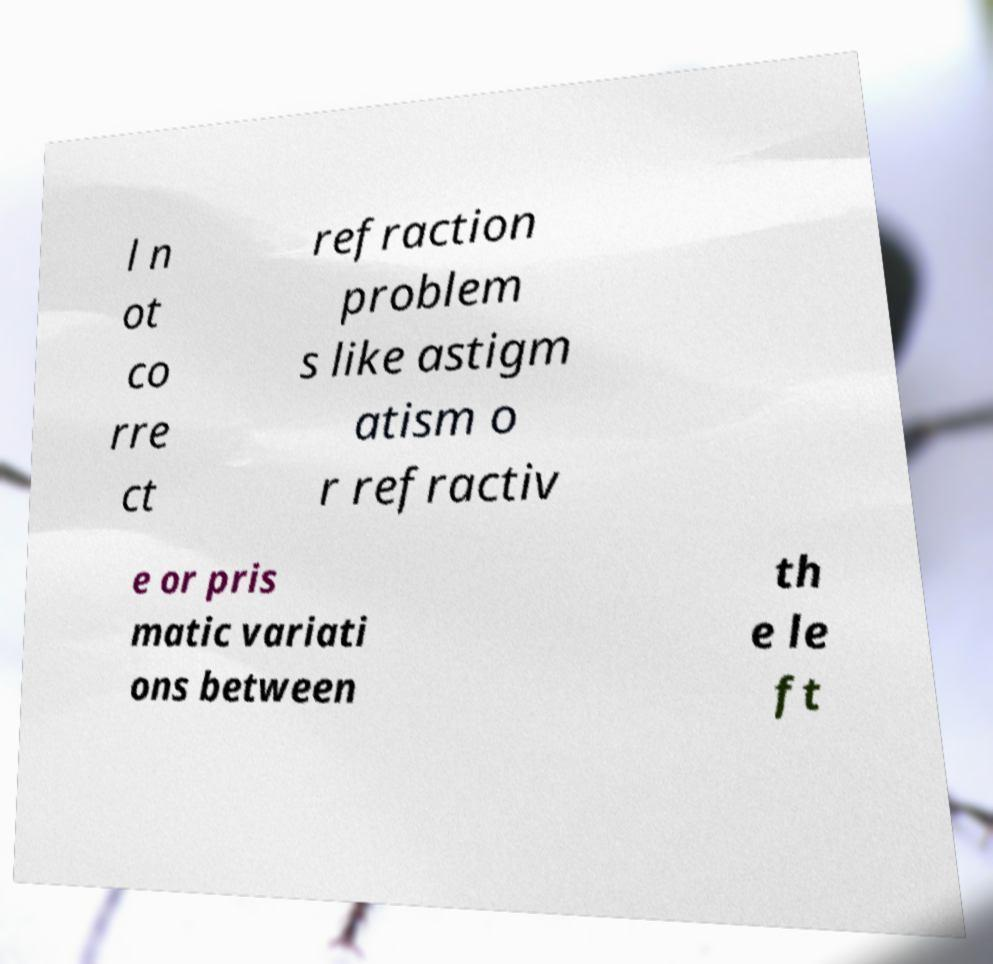Could you extract and type out the text from this image? l n ot co rre ct refraction problem s like astigm atism o r refractiv e or pris matic variati ons between th e le ft 